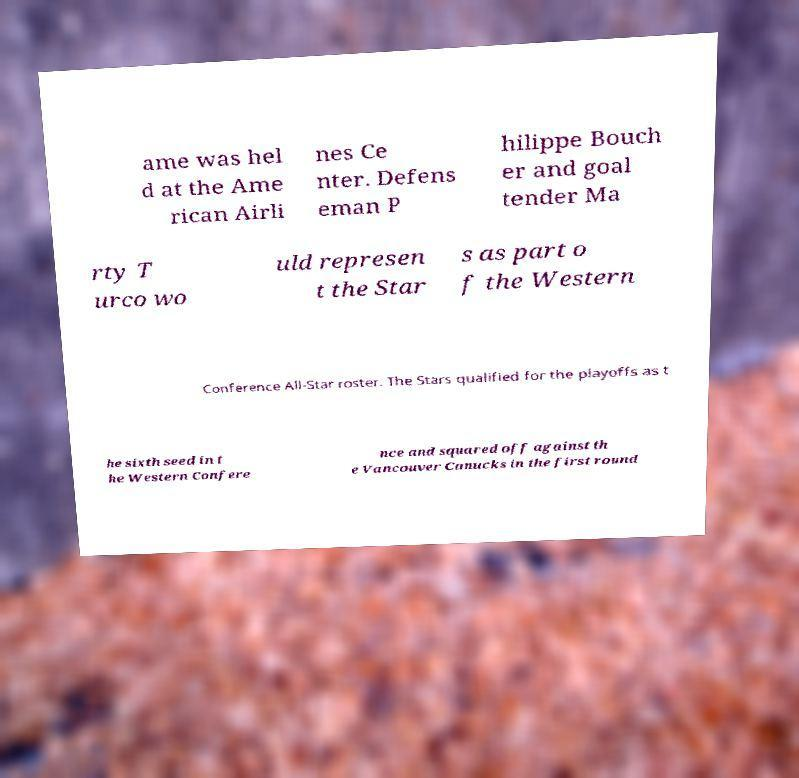Can you accurately transcribe the text from the provided image for me? ame was hel d at the Ame rican Airli nes Ce nter. Defens eman P hilippe Bouch er and goal tender Ma rty T urco wo uld represen t the Star s as part o f the Western Conference All-Star roster. The Stars qualified for the playoffs as t he sixth seed in t he Western Confere nce and squared off against th e Vancouver Canucks in the first round 